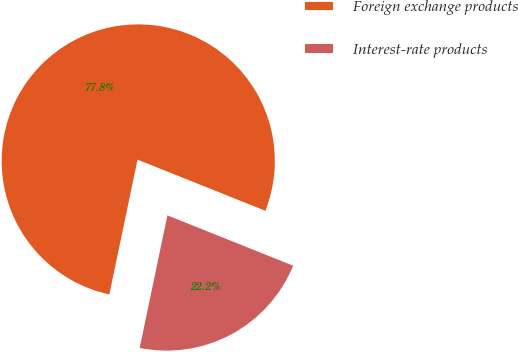<chart> <loc_0><loc_0><loc_500><loc_500><pie_chart><fcel>Foreign exchange products<fcel>Interest-rate products<nl><fcel>77.78%<fcel>22.22%<nl></chart> 